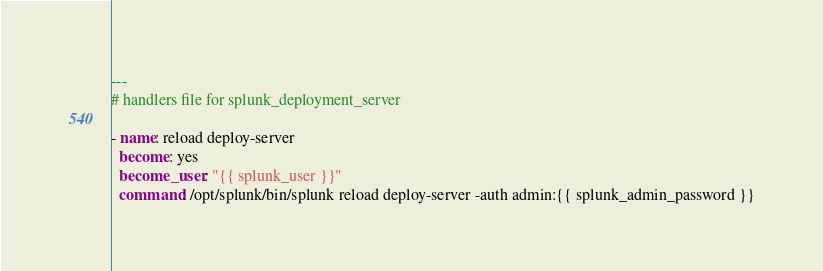<code> <loc_0><loc_0><loc_500><loc_500><_YAML_>---
# handlers file for splunk_deployment_server

- name: reload deploy-server
  become: yes
  become_user: "{{ splunk_user }}"
  command: /opt/splunk/bin/splunk reload deploy-server -auth admin:{{ splunk_admin_password }}
</code> 